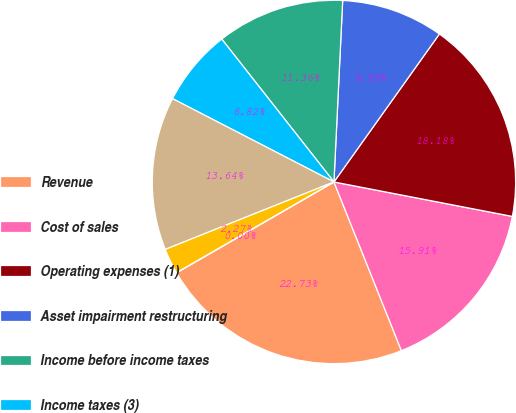Convert chart to OTSL. <chart><loc_0><loc_0><loc_500><loc_500><pie_chart><fcel>Revenue<fcel>Cost of sales<fcel>Operating expenses (1)<fcel>Asset impairment restructuring<fcel>Income before income taxes<fcel>Income taxes (3)<fcel>Net income (loss)<fcel>Earnings (loss) per<fcel>Dividends paid per share<nl><fcel>22.73%<fcel>15.91%<fcel>18.18%<fcel>9.09%<fcel>11.36%<fcel>6.82%<fcel>13.64%<fcel>2.27%<fcel>0.0%<nl></chart> 